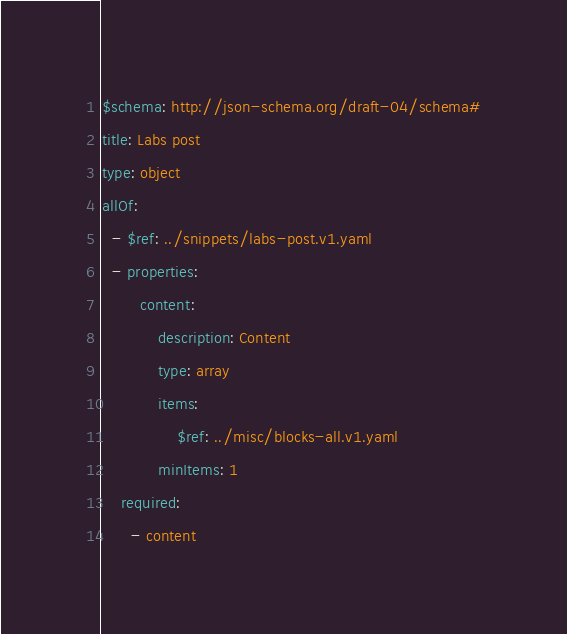<code> <loc_0><loc_0><loc_500><loc_500><_YAML_>$schema: http://json-schema.org/draft-04/schema#
title: Labs post
type: object
allOf:
  - $ref: ../snippets/labs-post.v1.yaml
  - properties:
        content:
            description: Content
            type: array
            items:
                $ref: ../misc/blocks-all.v1.yaml
            minItems: 1
    required:
      - content
</code> 